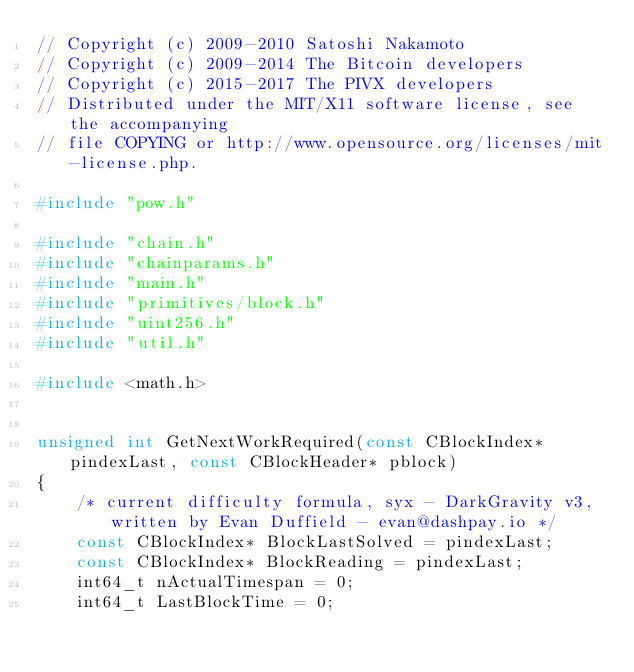Convert code to text. <code><loc_0><loc_0><loc_500><loc_500><_C++_>// Copyright (c) 2009-2010 Satoshi Nakamoto
// Copyright (c) 2009-2014 The Bitcoin developers
// Copyright (c) 2015-2017 The PIVX developers
// Distributed under the MIT/X11 software license, see the accompanying
// file COPYING or http://www.opensource.org/licenses/mit-license.php.

#include "pow.h"

#include "chain.h"
#include "chainparams.h"
#include "main.h"
#include "primitives/block.h"
#include "uint256.h"
#include "util.h"

#include <math.h>


unsigned int GetNextWorkRequired(const CBlockIndex* pindexLast, const CBlockHeader* pblock)
{
    /* current difficulty formula, syx - DarkGravity v3, written by Evan Duffield - evan@dashpay.io */
    const CBlockIndex* BlockLastSolved = pindexLast;
    const CBlockIndex* BlockReading = pindexLast;
    int64_t nActualTimespan = 0;
    int64_t LastBlockTime = 0;</code> 